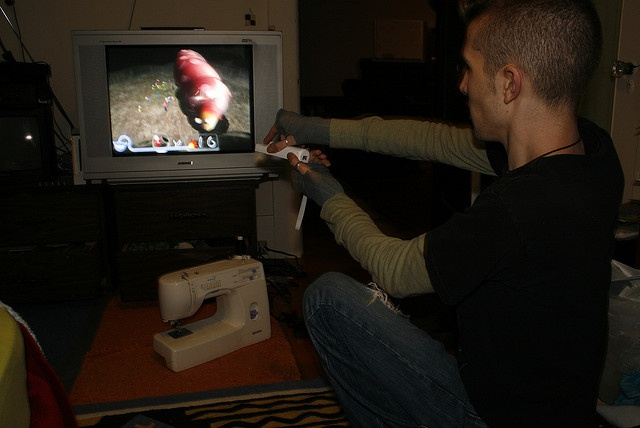Describe the objects in this image and their specific colors. I can see people in black, maroon, and gray tones, tv in black, gray, and darkgray tones, and remote in black and gray tones in this image. 